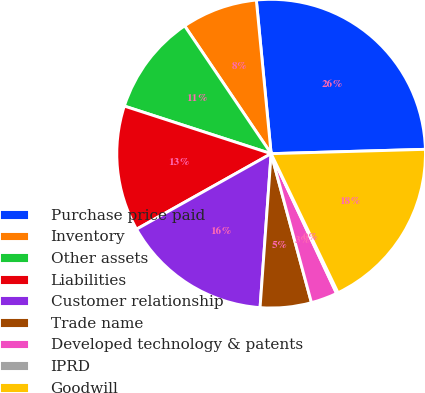<chart> <loc_0><loc_0><loc_500><loc_500><pie_chart><fcel>Purchase price paid<fcel>Inventory<fcel>Other assets<fcel>Liabilities<fcel>Customer relationship<fcel>Trade name<fcel>Developed technology & patents<fcel>IPRD<fcel>Goodwill<nl><fcel>26.08%<fcel>7.94%<fcel>10.54%<fcel>13.13%<fcel>15.72%<fcel>5.35%<fcel>2.76%<fcel>0.17%<fcel>18.31%<nl></chart> 